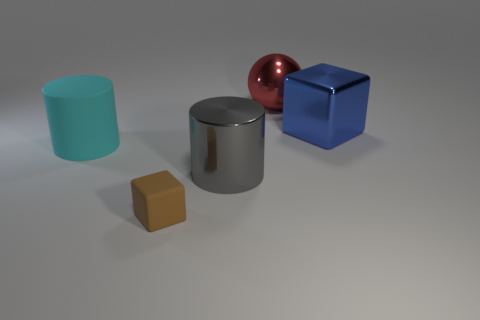Are there more big gray metallic objects that are in front of the small rubber block than big brown rubber cylinders?
Provide a succinct answer. No. How many metallic things are behind the blue metal block and in front of the red thing?
Make the answer very short. 0. There is a cube on the left side of the object that is to the right of the large red shiny object; what color is it?
Your answer should be very brief. Brown. What number of other matte things have the same color as the tiny thing?
Ensure brevity in your answer.  0. There is a big metal cube; is it the same color as the thing that is behind the metallic cube?
Keep it short and to the point. No. Is the number of gray metallic cylinders less than the number of big brown matte things?
Offer a very short reply. No. Is the number of big cubes in front of the big cyan cylinder greater than the number of brown matte objects behind the large shiny block?
Keep it short and to the point. No. Are the small brown thing and the large block made of the same material?
Provide a short and direct response. No. What number of small matte objects are in front of the thing that is on the left side of the tiny brown cube?
Give a very brief answer. 1. There is a cylinder that is right of the brown matte object; is its color the same as the large sphere?
Keep it short and to the point. No. 